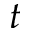Convert formula to latex. <formula><loc_0><loc_0><loc_500><loc_500>t</formula> 